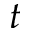Convert formula to latex. <formula><loc_0><loc_0><loc_500><loc_500>t</formula> 